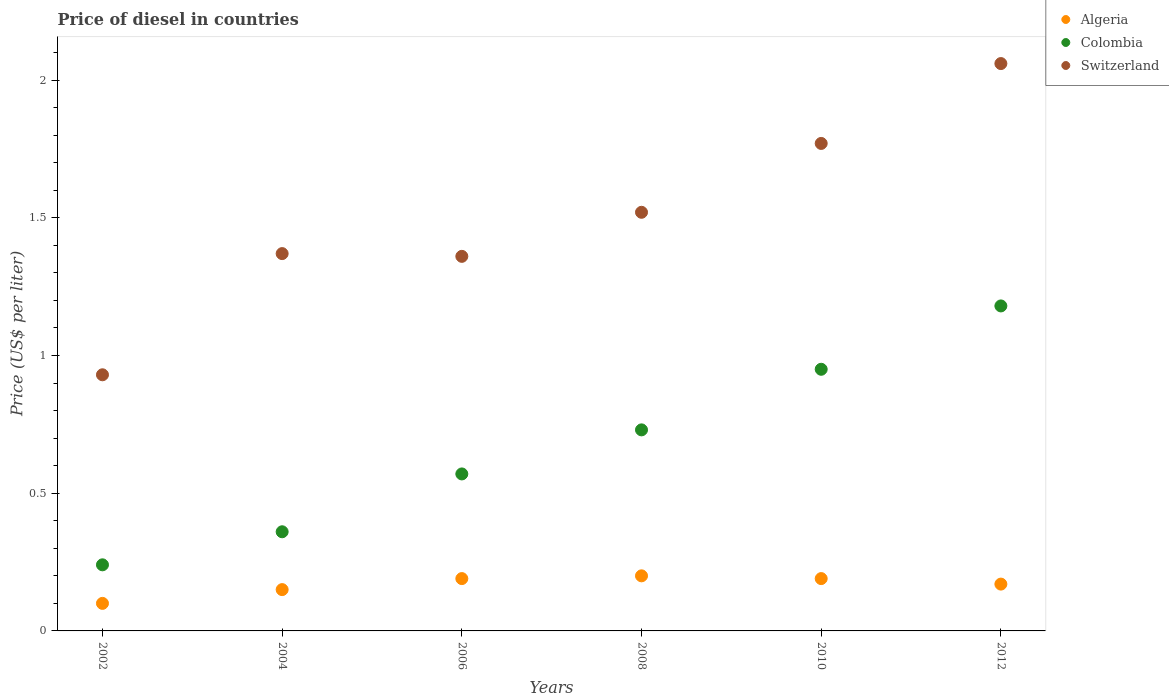Is the number of dotlines equal to the number of legend labels?
Your answer should be very brief. Yes. What is the price of diesel in Switzerland in 2006?
Your answer should be compact. 1.36. Across all years, what is the maximum price of diesel in Colombia?
Offer a terse response. 1.18. Across all years, what is the minimum price of diesel in Colombia?
Keep it short and to the point. 0.24. In which year was the price of diesel in Colombia maximum?
Make the answer very short. 2012. What is the total price of diesel in Colombia in the graph?
Ensure brevity in your answer.  4.03. What is the difference between the price of diesel in Switzerland in 2010 and that in 2012?
Your response must be concise. -0.29. What is the difference between the price of diesel in Colombia in 2006 and the price of diesel in Algeria in 2002?
Your answer should be very brief. 0.47. What is the average price of diesel in Colombia per year?
Offer a very short reply. 0.67. In the year 2004, what is the difference between the price of diesel in Switzerland and price of diesel in Algeria?
Provide a short and direct response. 1.22. In how many years, is the price of diesel in Colombia greater than 1 US$?
Your answer should be compact. 1. What is the ratio of the price of diesel in Colombia in 2004 to that in 2012?
Offer a very short reply. 0.31. Is the price of diesel in Switzerland in 2006 less than that in 2010?
Give a very brief answer. Yes. What is the difference between the highest and the second highest price of diesel in Colombia?
Offer a terse response. 0.23. What is the difference between the highest and the lowest price of diesel in Switzerland?
Give a very brief answer. 1.13. In how many years, is the price of diesel in Algeria greater than the average price of diesel in Algeria taken over all years?
Provide a succinct answer. 4. Is the sum of the price of diesel in Algeria in 2004 and 2010 greater than the maximum price of diesel in Switzerland across all years?
Provide a short and direct response. No. Is it the case that in every year, the sum of the price of diesel in Algeria and price of diesel in Switzerland  is greater than the price of diesel in Colombia?
Give a very brief answer. Yes. Does the price of diesel in Switzerland monotonically increase over the years?
Keep it short and to the point. No. Is the price of diesel in Switzerland strictly less than the price of diesel in Colombia over the years?
Offer a terse response. No. How many years are there in the graph?
Your response must be concise. 6. What is the difference between two consecutive major ticks on the Y-axis?
Your answer should be compact. 0.5. What is the title of the graph?
Give a very brief answer. Price of diesel in countries. Does "Grenada" appear as one of the legend labels in the graph?
Offer a very short reply. No. What is the label or title of the Y-axis?
Ensure brevity in your answer.  Price (US$ per liter). What is the Price (US$ per liter) of Colombia in 2002?
Your answer should be compact. 0.24. What is the Price (US$ per liter) in Switzerland in 2002?
Your answer should be compact. 0.93. What is the Price (US$ per liter) of Colombia in 2004?
Make the answer very short. 0.36. What is the Price (US$ per liter) in Switzerland in 2004?
Provide a short and direct response. 1.37. What is the Price (US$ per liter) of Algeria in 2006?
Offer a terse response. 0.19. What is the Price (US$ per liter) in Colombia in 2006?
Provide a succinct answer. 0.57. What is the Price (US$ per liter) of Switzerland in 2006?
Make the answer very short. 1.36. What is the Price (US$ per liter) of Algeria in 2008?
Keep it short and to the point. 0.2. What is the Price (US$ per liter) of Colombia in 2008?
Your answer should be compact. 0.73. What is the Price (US$ per liter) of Switzerland in 2008?
Make the answer very short. 1.52. What is the Price (US$ per liter) of Algeria in 2010?
Your answer should be very brief. 0.19. What is the Price (US$ per liter) in Colombia in 2010?
Your response must be concise. 0.95. What is the Price (US$ per liter) in Switzerland in 2010?
Keep it short and to the point. 1.77. What is the Price (US$ per liter) in Algeria in 2012?
Your answer should be compact. 0.17. What is the Price (US$ per liter) in Colombia in 2012?
Provide a short and direct response. 1.18. What is the Price (US$ per liter) of Switzerland in 2012?
Keep it short and to the point. 2.06. Across all years, what is the maximum Price (US$ per liter) in Colombia?
Provide a short and direct response. 1.18. Across all years, what is the maximum Price (US$ per liter) of Switzerland?
Give a very brief answer. 2.06. Across all years, what is the minimum Price (US$ per liter) of Colombia?
Your answer should be very brief. 0.24. Across all years, what is the minimum Price (US$ per liter) in Switzerland?
Ensure brevity in your answer.  0.93. What is the total Price (US$ per liter) of Algeria in the graph?
Offer a very short reply. 1. What is the total Price (US$ per liter) of Colombia in the graph?
Your response must be concise. 4.03. What is the total Price (US$ per liter) in Switzerland in the graph?
Offer a terse response. 9.01. What is the difference between the Price (US$ per liter) of Algeria in 2002 and that in 2004?
Keep it short and to the point. -0.05. What is the difference between the Price (US$ per liter) in Colombia in 2002 and that in 2004?
Ensure brevity in your answer.  -0.12. What is the difference between the Price (US$ per liter) in Switzerland in 2002 and that in 2004?
Provide a succinct answer. -0.44. What is the difference between the Price (US$ per liter) in Algeria in 2002 and that in 2006?
Keep it short and to the point. -0.09. What is the difference between the Price (US$ per liter) in Colombia in 2002 and that in 2006?
Your answer should be very brief. -0.33. What is the difference between the Price (US$ per liter) of Switzerland in 2002 and that in 2006?
Your answer should be compact. -0.43. What is the difference between the Price (US$ per liter) of Algeria in 2002 and that in 2008?
Make the answer very short. -0.1. What is the difference between the Price (US$ per liter) in Colombia in 2002 and that in 2008?
Provide a succinct answer. -0.49. What is the difference between the Price (US$ per liter) in Switzerland in 2002 and that in 2008?
Provide a succinct answer. -0.59. What is the difference between the Price (US$ per liter) of Algeria in 2002 and that in 2010?
Offer a very short reply. -0.09. What is the difference between the Price (US$ per liter) of Colombia in 2002 and that in 2010?
Ensure brevity in your answer.  -0.71. What is the difference between the Price (US$ per liter) of Switzerland in 2002 and that in 2010?
Provide a succinct answer. -0.84. What is the difference between the Price (US$ per liter) in Algeria in 2002 and that in 2012?
Your answer should be compact. -0.07. What is the difference between the Price (US$ per liter) of Colombia in 2002 and that in 2012?
Offer a very short reply. -0.94. What is the difference between the Price (US$ per liter) of Switzerland in 2002 and that in 2012?
Ensure brevity in your answer.  -1.13. What is the difference between the Price (US$ per liter) in Algeria in 2004 and that in 2006?
Your response must be concise. -0.04. What is the difference between the Price (US$ per liter) of Colombia in 2004 and that in 2006?
Give a very brief answer. -0.21. What is the difference between the Price (US$ per liter) of Switzerland in 2004 and that in 2006?
Your answer should be very brief. 0.01. What is the difference between the Price (US$ per liter) of Algeria in 2004 and that in 2008?
Provide a succinct answer. -0.05. What is the difference between the Price (US$ per liter) of Colombia in 2004 and that in 2008?
Provide a short and direct response. -0.37. What is the difference between the Price (US$ per liter) of Switzerland in 2004 and that in 2008?
Offer a very short reply. -0.15. What is the difference between the Price (US$ per liter) of Algeria in 2004 and that in 2010?
Your response must be concise. -0.04. What is the difference between the Price (US$ per liter) in Colombia in 2004 and that in 2010?
Keep it short and to the point. -0.59. What is the difference between the Price (US$ per liter) of Algeria in 2004 and that in 2012?
Make the answer very short. -0.02. What is the difference between the Price (US$ per liter) of Colombia in 2004 and that in 2012?
Make the answer very short. -0.82. What is the difference between the Price (US$ per liter) in Switzerland in 2004 and that in 2012?
Your answer should be compact. -0.69. What is the difference between the Price (US$ per liter) in Algeria in 2006 and that in 2008?
Keep it short and to the point. -0.01. What is the difference between the Price (US$ per liter) in Colombia in 2006 and that in 2008?
Keep it short and to the point. -0.16. What is the difference between the Price (US$ per liter) of Switzerland in 2006 and that in 2008?
Your answer should be compact. -0.16. What is the difference between the Price (US$ per liter) of Colombia in 2006 and that in 2010?
Your response must be concise. -0.38. What is the difference between the Price (US$ per liter) in Switzerland in 2006 and that in 2010?
Offer a very short reply. -0.41. What is the difference between the Price (US$ per liter) of Algeria in 2006 and that in 2012?
Make the answer very short. 0.02. What is the difference between the Price (US$ per liter) of Colombia in 2006 and that in 2012?
Your response must be concise. -0.61. What is the difference between the Price (US$ per liter) in Colombia in 2008 and that in 2010?
Offer a terse response. -0.22. What is the difference between the Price (US$ per liter) of Algeria in 2008 and that in 2012?
Ensure brevity in your answer.  0.03. What is the difference between the Price (US$ per liter) of Colombia in 2008 and that in 2012?
Offer a very short reply. -0.45. What is the difference between the Price (US$ per liter) of Switzerland in 2008 and that in 2012?
Provide a succinct answer. -0.54. What is the difference between the Price (US$ per liter) in Colombia in 2010 and that in 2012?
Provide a succinct answer. -0.23. What is the difference between the Price (US$ per liter) in Switzerland in 2010 and that in 2012?
Your answer should be compact. -0.29. What is the difference between the Price (US$ per liter) in Algeria in 2002 and the Price (US$ per liter) in Colombia in 2004?
Offer a terse response. -0.26. What is the difference between the Price (US$ per liter) in Algeria in 2002 and the Price (US$ per liter) in Switzerland in 2004?
Make the answer very short. -1.27. What is the difference between the Price (US$ per liter) of Colombia in 2002 and the Price (US$ per liter) of Switzerland in 2004?
Give a very brief answer. -1.13. What is the difference between the Price (US$ per liter) of Algeria in 2002 and the Price (US$ per liter) of Colombia in 2006?
Your answer should be very brief. -0.47. What is the difference between the Price (US$ per liter) in Algeria in 2002 and the Price (US$ per liter) in Switzerland in 2006?
Keep it short and to the point. -1.26. What is the difference between the Price (US$ per liter) of Colombia in 2002 and the Price (US$ per liter) of Switzerland in 2006?
Offer a terse response. -1.12. What is the difference between the Price (US$ per liter) of Algeria in 2002 and the Price (US$ per liter) of Colombia in 2008?
Make the answer very short. -0.63. What is the difference between the Price (US$ per liter) of Algeria in 2002 and the Price (US$ per liter) of Switzerland in 2008?
Keep it short and to the point. -1.42. What is the difference between the Price (US$ per liter) in Colombia in 2002 and the Price (US$ per liter) in Switzerland in 2008?
Your answer should be very brief. -1.28. What is the difference between the Price (US$ per liter) in Algeria in 2002 and the Price (US$ per liter) in Colombia in 2010?
Your answer should be very brief. -0.85. What is the difference between the Price (US$ per liter) in Algeria in 2002 and the Price (US$ per liter) in Switzerland in 2010?
Ensure brevity in your answer.  -1.67. What is the difference between the Price (US$ per liter) in Colombia in 2002 and the Price (US$ per liter) in Switzerland in 2010?
Offer a terse response. -1.53. What is the difference between the Price (US$ per liter) of Algeria in 2002 and the Price (US$ per liter) of Colombia in 2012?
Your answer should be compact. -1.08. What is the difference between the Price (US$ per liter) in Algeria in 2002 and the Price (US$ per liter) in Switzerland in 2012?
Your answer should be compact. -1.96. What is the difference between the Price (US$ per liter) in Colombia in 2002 and the Price (US$ per liter) in Switzerland in 2012?
Provide a short and direct response. -1.82. What is the difference between the Price (US$ per liter) of Algeria in 2004 and the Price (US$ per liter) of Colombia in 2006?
Your answer should be compact. -0.42. What is the difference between the Price (US$ per liter) in Algeria in 2004 and the Price (US$ per liter) in Switzerland in 2006?
Ensure brevity in your answer.  -1.21. What is the difference between the Price (US$ per liter) in Algeria in 2004 and the Price (US$ per liter) in Colombia in 2008?
Ensure brevity in your answer.  -0.58. What is the difference between the Price (US$ per liter) of Algeria in 2004 and the Price (US$ per liter) of Switzerland in 2008?
Your answer should be compact. -1.37. What is the difference between the Price (US$ per liter) of Colombia in 2004 and the Price (US$ per liter) of Switzerland in 2008?
Ensure brevity in your answer.  -1.16. What is the difference between the Price (US$ per liter) in Algeria in 2004 and the Price (US$ per liter) in Colombia in 2010?
Your answer should be compact. -0.8. What is the difference between the Price (US$ per liter) in Algeria in 2004 and the Price (US$ per liter) in Switzerland in 2010?
Offer a very short reply. -1.62. What is the difference between the Price (US$ per liter) of Colombia in 2004 and the Price (US$ per liter) of Switzerland in 2010?
Your answer should be compact. -1.41. What is the difference between the Price (US$ per liter) of Algeria in 2004 and the Price (US$ per liter) of Colombia in 2012?
Offer a very short reply. -1.03. What is the difference between the Price (US$ per liter) of Algeria in 2004 and the Price (US$ per liter) of Switzerland in 2012?
Provide a succinct answer. -1.91. What is the difference between the Price (US$ per liter) of Colombia in 2004 and the Price (US$ per liter) of Switzerland in 2012?
Provide a short and direct response. -1.7. What is the difference between the Price (US$ per liter) of Algeria in 2006 and the Price (US$ per liter) of Colombia in 2008?
Offer a very short reply. -0.54. What is the difference between the Price (US$ per liter) in Algeria in 2006 and the Price (US$ per liter) in Switzerland in 2008?
Provide a succinct answer. -1.33. What is the difference between the Price (US$ per liter) of Colombia in 2006 and the Price (US$ per liter) of Switzerland in 2008?
Your answer should be very brief. -0.95. What is the difference between the Price (US$ per liter) in Algeria in 2006 and the Price (US$ per liter) in Colombia in 2010?
Offer a very short reply. -0.76. What is the difference between the Price (US$ per liter) of Algeria in 2006 and the Price (US$ per liter) of Switzerland in 2010?
Provide a succinct answer. -1.58. What is the difference between the Price (US$ per liter) of Colombia in 2006 and the Price (US$ per liter) of Switzerland in 2010?
Provide a short and direct response. -1.2. What is the difference between the Price (US$ per liter) in Algeria in 2006 and the Price (US$ per liter) in Colombia in 2012?
Ensure brevity in your answer.  -0.99. What is the difference between the Price (US$ per liter) in Algeria in 2006 and the Price (US$ per liter) in Switzerland in 2012?
Keep it short and to the point. -1.87. What is the difference between the Price (US$ per liter) of Colombia in 2006 and the Price (US$ per liter) of Switzerland in 2012?
Make the answer very short. -1.49. What is the difference between the Price (US$ per liter) of Algeria in 2008 and the Price (US$ per liter) of Colombia in 2010?
Your answer should be compact. -0.75. What is the difference between the Price (US$ per liter) of Algeria in 2008 and the Price (US$ per liter) of Switzerland in 2010?
Give a very brief answer. -1.57. What is the difference between the Price (US$ per liter) in Colombia in 2008 and the Price (US$ per liter) in Switzerland in 2010?
Make the answer very short. -1.04. What is the difference between the Price (US$ per liter) in Algeria in 2008 and the Price (US$ per liter) in Colombia in 2012?
Provide a short and direct response. -0.98. What is the difference between the Price (US$ per liter) of Algeria in 2008 and the Price (US$ per liter) of Switzerland in 2012?
Make the answer very short. -1.86. What is the difference between the Price (US$ per liter) in Colombia in 2008 and the Price (US$ per liter) in Switzerland in 2012?
Your answer should be compact. -1.33. What is the difference between the Price (US$ per liter) in Algeria in 2010 and the Price (US$ per liter) in Colombia in 2012?
Ensure brevity in your answer.  -0.99. What is the difference between the Price (US$ per liter) in Algeria in 2010 and the Price (US$ per liter) in Switzerland in 2012?
Keep it short and to the point. -1.87. What is the difference between the Price (US$ per liter) in Colombia in 2010 and the Price (US$ per liter) in Switzerland in 2012?
Your answer should be very brief. -1.11. What is the average Price (US$ per liter) in Algeria per year?
Offer a very short reply. 0.17. What is the average Price (US$ per liter) in Colombia per year?
Offer a very short reply. 0.67. What is the average Price (US$ per liter) of Switzerland per year?
Provide a succinct answer. 1.5. In the year 2002, what is the difference between the Price (US$ per liter) of Algeria and Price (US$ per liter) of Colombia?
Your answer should be very brief. -0.14. In the year 2002, what is the difference between the Price (US$ per liter) in Algeria and Price (US$ per liter) in Switzerland?
Your answer should be compact. -0.83. In the year 2002, what is the difference between the Price (US$ per liter) in Colombia and Price (US$ per liter) in Switzerland?
Keep it short and to the point. -0.69. In the year 2004, what is the difference between the Price (US$ per liter) of Algeria and Price (US$ per liter) of Colombia?
Offer a very short reply. -0.21. In the year 2004, what is the difference between the Price (US$ per liter) of Algeria and Price (US$ per liter) of Switzerland?
Keep it short and to the point. -1.22. In the year 2004, what is the difference between the Price (US$ per liter) of Colombia and Price (US$ per liter) of Switzerland?
Offer a very short reply. -1.01. In the year 2006, what is the difference between the Price (US$ per liter) in Algeria and Price (US$ per liter) in Colombia?
Your answer should be very brief. -0.38. In the year 2006, what is the difference between the Price (US$ per liter) in Algeria and Price (US$ per liter) in Switzerland?
Make the answer very short. -1.17. In the year 2006, what is the difference between the Price (US$ per liter) of Colombia and Price (US$ per liter) of Switzerland?
Ensure brevity in your answer.  -0.79. In the year 2008, what is the difference between the Price (US$ per liter) of Algeria and Price (US$ per liter) of Colombia?
Ensure brevity in your answer.  -0.53. In the year 2008, what is the difference between the Price (US$ per liter) of Algeria and Price (US$ per liter) of Switzerland?
Your response must be concise. -1.32. In the year 2008, what is the difference between the Price (US$ per liter) in Colombia and Price (US$ per liter) in Switzerland?
Your response must be concise. -0.79. In the year 2010, what is the difference between the Price (US$ per liter) in Algeria and Price (US$ per liter) in Colombia?
Provide a succinct answer. -0.76. In the year 2010, what is the difference between the Price (US$ per liter) of Algeria and Price (US$ per liter) of Switzerland?
Ensure brevity in your answer.  -1.58. In the year 2010, what is the difference between the Price (US$ per liter) in Colombia and Price (US$ per liter) in Switzerland?
Make the answer very short. -0.82. In the year 2012, what is the difference between the Price (US$ per liter) in Algeria and Price (US$ per liter) in Colombia?
Your answer should be compact. -1.01. In the year 2012, what is the difference between the Price (US$ per liter) in Algeria and Price (US$ per liter) in Switzerland?
Make the answer very short. -1.89. In the year 2012, what is the difference between the Price (US$ per liter) in Colombia and Price (US$ per liter) in Switzerland?
Provide a short and direct response. -0.88. What is the ratio of the Price (US$ per liter) of Algeria in 2002 to that in 2004?
Give a very brief answer. 0.67. What is the ratio of the Price (US$ per liter) of Colombia in 2002 to that in 2004?
Give a very brief answer. 0.67. What is the ratio of the Price (US$ per liter) in Switzerland in 2002 to that in 2004?
Offer a terse response. 0.68. What is the ratio of the Price (US$ per liter) of Algeria in 2002 to that in 2006?
Your answer should be very brief. 0.53. What is the ratio of the Price (US$ per liter) of Colombia in 2002 to that in 2006?
Make the answer very short. 0.42. What is the ratio of the Price (US$ per liter) in Switzerland in 2002 to that in 2006?
Provide a succinct answer. 0.68. What is the ratio of the Price (US$ per liter) in Algeria in 2002 to that in 2008?
Keep it short and to the point. 0.5. What is the ratio of the Price (US$ per liter) of Colombia in 2002 to that in 2008?
Keep it short and to the point. 0.33. What is the ratio of the Price (US$ per liter) of Switzerland in 2002 to that in 2008?
Offer a terse response. 0.61. What is the ratio of the Price (US$ per liter) in Algeria in 2002 to that in 2010?
Give a very brief answer. 0.53. What is the ratio of the Price (US$ per liter) in Colombia in 2002 to that in 2010?
Ensure brevity in your answer.  0.25. What is the ratio of the Price (US$ per liter) of Switzerland in 2002 to that in 2010?
Keep it short and to the point. 0.53. What is the ratio of the Price (US$ per liter) in Algeria in 2002 to that in 2012?
Make the answer very short. 0.59. What is the ratio of the Price (US$ per liter) in Colombia in 2002 to that in 2012?
Offer a very short reply. 0.2. What is the ratio of the Price (US$ per liter) of Switzerland in 2002 to that in 2012?
Provide a succinct answer. 0.45. What is the ratio of the Price (US$ per liter) in Algeria in 2004 to that in 2006?
Offer a very short reply. 0.79. What is the ratio of the Price (US$ per liter) in Colombia in 2004 to that in 2006?
Your answer should be very brief. 0.63. What is the ratio of the Price (US$ per liter) in Switzerland in 2004 to that in 2006?
Ensure brevity in your answer.  1.01. What is the ratio of the Price (US$ per liter) of Algeria in 2004 to that in 2008?
Your response must be concise. 0.75. What is the ratio of the Price (US$ per liter) of Colombia in 2004 to that in 2008?
Ensure brevity in your answer.  0.49. What is the ratio of the Price (US$ per liter) in Switzerland in 2004 to that in 2008?
Your answer should be compact. 0.9. What is the ratio of the Price (US$ per liter) of Algeria in 2004 to that in 2010?
Make the answer very short. 0.79. What is the ratio of the Price (US$ per liter) in Colombia in 2004 to that in 2010?
Provide a short and direct response. 0.38. What is the ratio of the Price (US$ per liter) in Switzerland in 2004 to that in 2010?
Give a very brief answer. 0.77. What is the ratio of the Price (US$ per liter) in Algeria in 2004 to that in 2012?
Offer a terse response. 0.88. What is the ratio of the Price (US$ per liter) in Colombia in 2004 to that in 2012?
Provide a short and direct response. 0.31. What is the ratio of the Price (US$ per liter) of Switzerland in 2004 to that in 2012?
Offer a terse response. 0.67. What is the ratio of the Price (US$ per liter) of Algeria in 2006 to that in 2008?
Make the answer very short. 0.95. What is the ratio of the Price (US$ per liter) of Colombia in 2006 to that in 2008?
Offer a very short reply. 0.78. What is the ratio of the Price (US$ per liter) in Switzerland in 2006 to that in 2008?
Offer a terse response. 0.89. What is the ratio of the Price (US$ per liter) of Algeria in 2006 to that in 2010?
Ensure brevity in your answer.  1. What is the ratio of the Price (US$ per liter) in Switzerland in 2006 to that in 2010?
Ensure brevity in your answer.  0.77. What is the ratio of the Price (US$ per liter) in Algeria in 2006 to that in 2012?
Your answer should be very brief. 1.12. What is the ratio of the Price (US$ per liter) in Colombia in 2006 to that in 2012?
Your answer should be very brief. 0.48. What is the ratio of the Price (US$ per liter) in Switzerland in 2006 to that in 2012?
Your answer should be compact. 0.66. What is the ratio of the Price (US$ per liter) in Algeria in 2008 to that in 2010?
Ensure brevity in your answer.  1.05. What is the ratio of the Price (US$ per liter) of Colombia in 2008 to that in 2010?
Provide a short and direct response. 0.77. What is the ratio of the Price (US$ per liter) in Switzerland in 2008 to that in 2010?
Your response must be concise. 0.86. What is the ratio of the Price (US$ per liter) in Algeria in 2008 to that in 2012?
Your response must be concise. 1.18. What is the ratio of the Price (US$ per liter) in Colombia in 2008 to that in 2012?
Offer a terse response. 0.62. What is the ratio of the Price (US$ per liter) of Switzerland in 2008 to that in 2012?
Offer a terse response. 0.74. What is the ratio of the Price (US$ per liter) of Algeria in 2010 to that in 2012?
Ensure brevity in your answer.  1.12. What is the ratio of the Price (US$ per liter) in Colombia in 2010 to that in 2012?
Provide a succinct answer. 0.81. What is the ratio of the Price (US$ per liter) in Switzerland in 2010 to that in 2012?
Provide a short and direct response. 0.86. What is the difference between the highest and the second highest Price (US$ per liter) of Colombia?
Your answer should be very brief. 0.23. What is the difference between the highest and the second highest Price (US$ per liter) of Switzerland?
Give a very brief answer. 0.29. What is the difference between the highest and the lowest Price (US$ per liter) in Algeria?
Make the answer very short. 0.1. What is the difference between the highest and the lowest Price (US$ per liter) of Switzerland?
Your answer should be very brief. 1.13. 